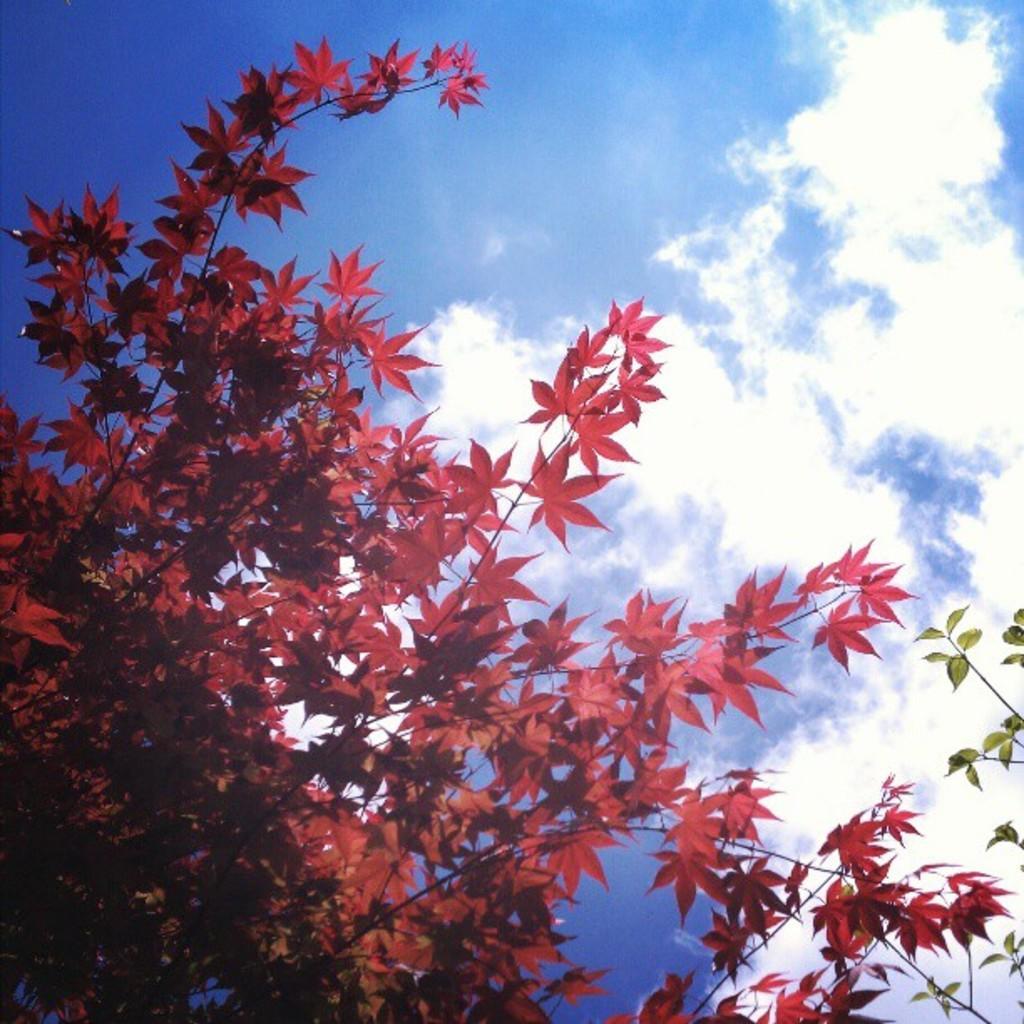How would you summarize this image in a sentence or two? In this image I see the red leaves and green leaves on the stems and I see the sky which is white and blue in color. 